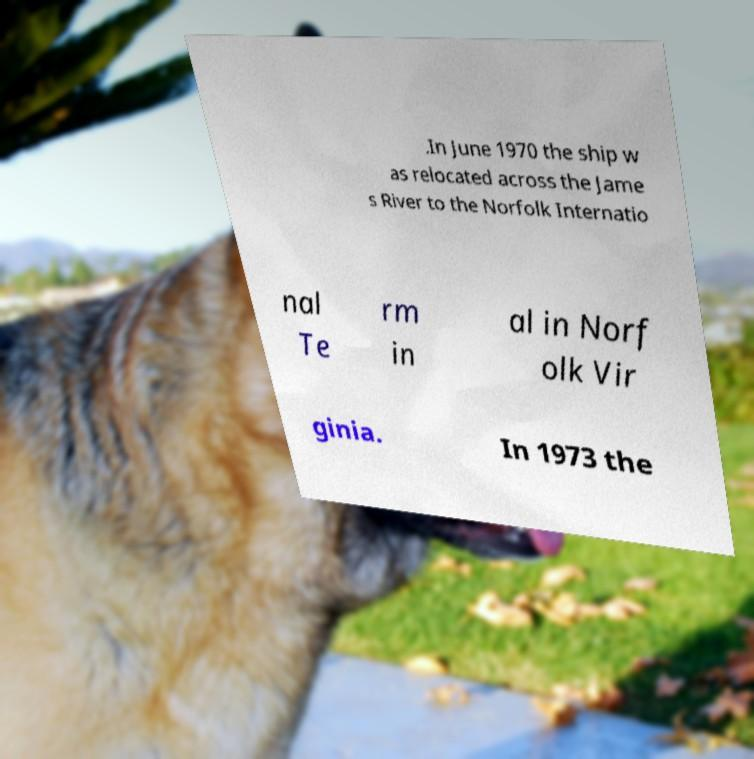Could you assist in decoding the text presented in this image and type it out clearly? .In June 1970 the ship w as relocated across the Jame s River to the Norfolk Internatio nal Te rm in al in Norf olk Vir ginia. In 1973 the 